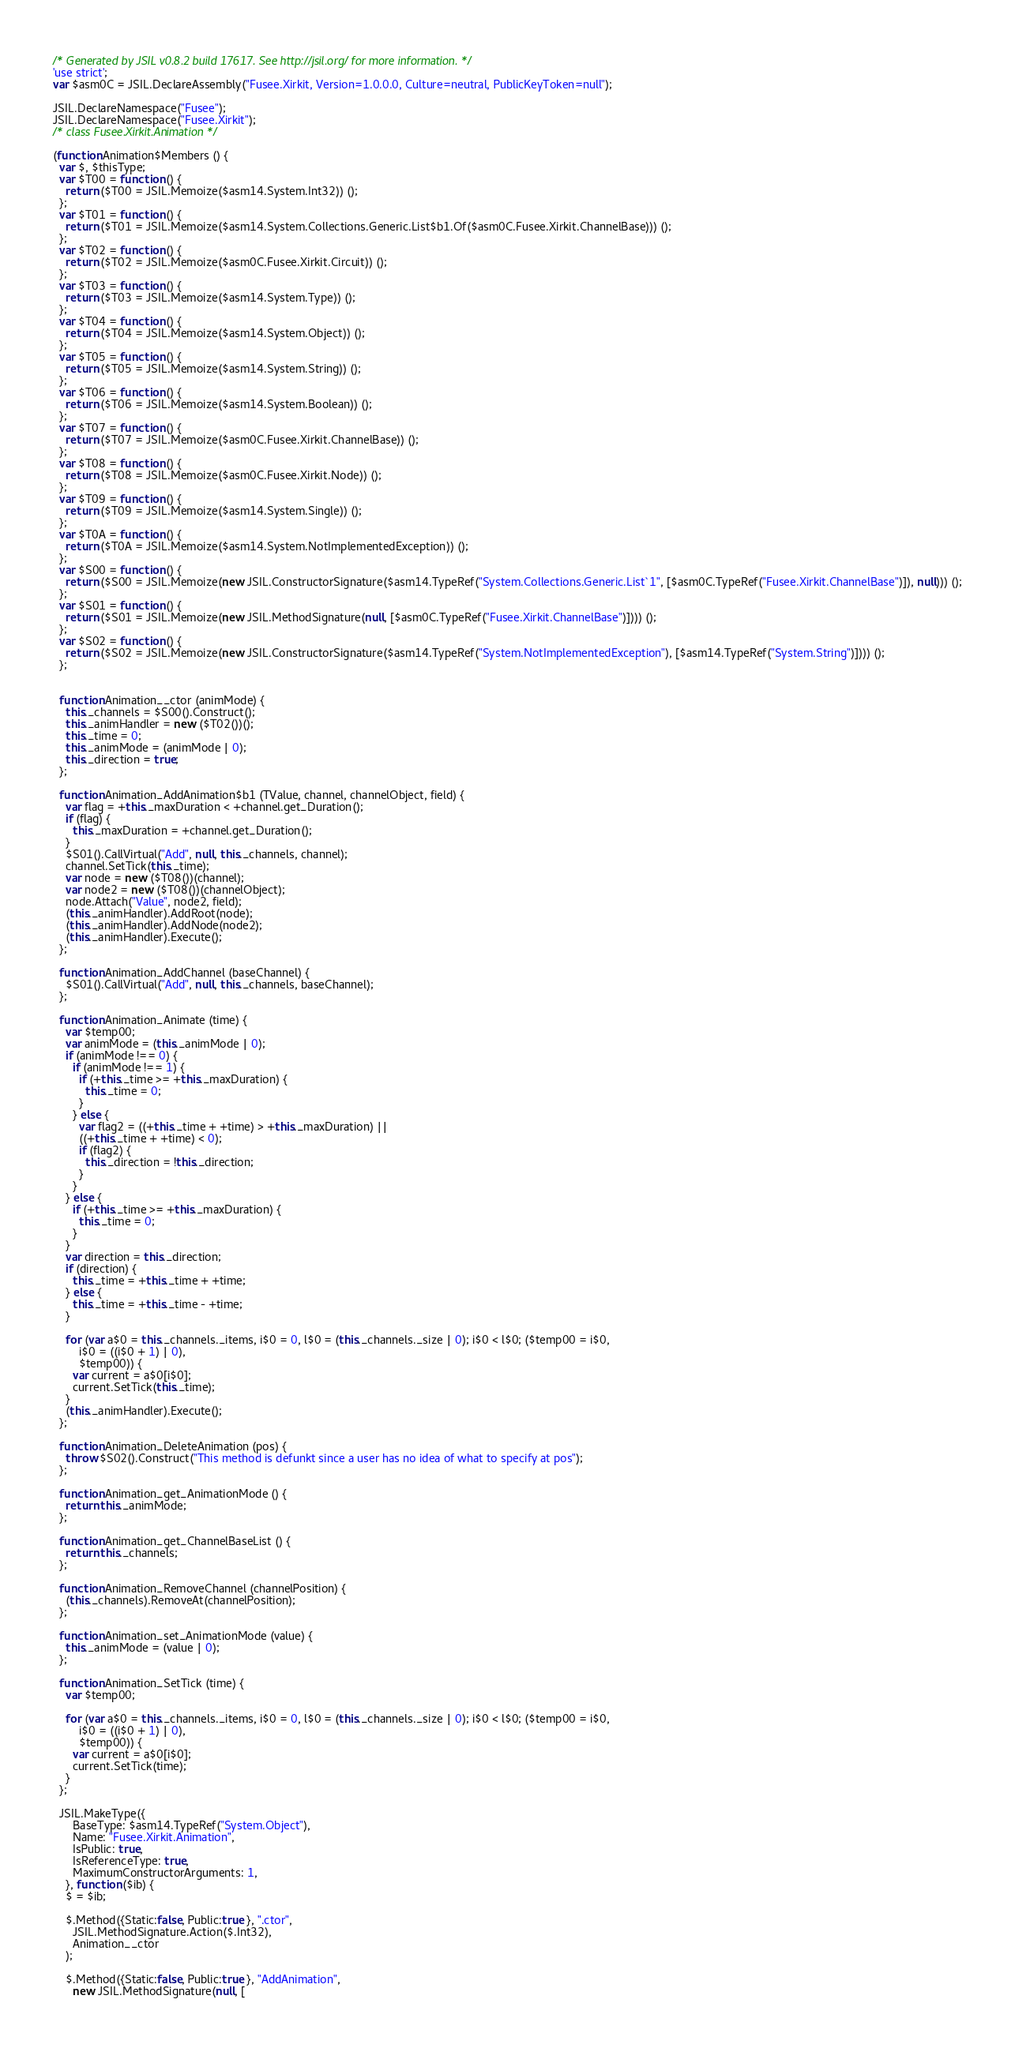Convert code to text. <code><loc_0><loc_0><loc_500><loc_500><_JavaScript_>/* Generated by JSIL v0.8.2 build 17617. See http://jsil.org/ for more information. */ 
'use strict';
var $asm0C = JSIL.DeclareAssembly("Fusee.Xirkit, Version=1.0.0.0, Culture=neutral, PublicKeyToken=null");

JSIL.DeclareNamespace("Fusee");
JSIL.DeclareNamespace("Fusee.Xirkit");
/* class Fusee.Xirkit.Animation */ 

(function Animation$Members () {
  var $, $thisType;
  var $T00 = function () {
    return ($T00 = JSIL.Memoize($asm14.System.Int32)) ();
  };
  var $T01 = function () {
    return ($T01 = JSIL.Memoize($asm14.System.Collections.Generic.List$b1.Of($asm0C.Fusee.Xirkit.ChannelBase))) ();
  };
  var $T02 = function () {
    return ($T02 = JSIL.Memoize($asm0C.Fusee.Xirkit.Circuit)) ();
  };
  var $T03 = function () {
    return ($T03 = JSIL.Memoize($asm14.System.Type)) ();
  };
  var $T04 = function () {
    return ($T04 = JSIL.Memoize($asm14.System.Object)) ();
  };
  var $T05 = function () {
    return ($T05 = JSIL.Memoize($asm14.System.String)) ();
  };
  var $T06 = function () {
    return ($T06 = JSIL.Memoize($asm14.System.Boolean)) ();
  };
  var $T07 = function () {
    return ($T07 = JSIL.Memoize($asm0C.Fusee.Xirkit.ChannelBase)) ();
  };
  var $T08 = function () {
    return ($T08 = JSIL.Memoize($asm0C.Fusee.Xirkit.Node)) ();
  };
  var $T09 = function () {
    return ($T09 = JSIL.Memoize($asm14.System.Single)) ();
  };
  var $T0A = function () {
    return ($T0A = JSIL.Memoize($asm14.System.NotImplementedException)) ();
  };
  var $S00 = function () {
    return ($S00 = JSIL.Memoize(new JSIL.ConstructorSignature($asm14.TypeRef("System.Collections.Generic.List`1", [$asm0C.TypeRef("Fusee.Xirkit.ChannelBase")]), null))) ();
  };
  var $S01 = function () {
    return ($S01 = JSIL.Memoize(new JSIL.MethodSignature(null, [$asm0C.TypeRef("Fusee.Xirkit.ChannelBase")]))) ();
  };
  var $S02 = function () {
    return ($S02 = JSIL.Memoize(new JSIL.ConstructorSignature($asm14.TypeRef("System.NotImplementedException"), [$asm14.TypeRef("System.String")]))) ();
  };


  function Animation__ctor (animMode) {
    this._channels = $S00().Construct();
    this._animHandler = new ($T02())();
    this._time = 0;
    this._animMode = (animMode | 0);
    this._direction = true;
  }; 

  function Animation_AddAnimation$b1 (TValue, channel, channelObject, field) {
    var flag = +this._maxDuration < +channel.get_Duration();
    if (flag) {
      this._maxDuration = +channel.get_Duration();
    }
    $S01().CallVirtual("Add", null, this._channels, channel);
    channel.SetTick(this._time);
    var node = new ($T08())(channel);
    var node2 = new ($T08())(channelObject);
    node.Attach("Value", node2, field);
    (this._animHandler).AddRoot(node);
    (this._animHandler).AddNode(node2);
    (this._animHandler).Execute();
  }; 

  function Animation_AddChannel (baseChannel) {
    $S01().CallVirtual("Add", null, this._channels, baseChannel);
  }; 

  function Animation_Animate (time) {
    var $temp00;
    var animMode = (this._animMode | 0);
    if (animMode !== 0) {
      if (animMode !== 1) {
        if (+this._time >= +this._maxDuration) {
          this._time = 0;
        }
      } else {
        var flag2 = ((+this._time + +time) > +this._maxDuration) || 
        ((+this._time + +time) < 0);
        if (flag2) {
          this._direction = !this._direction;
        }
      }
    } else {
      if (+this._time >= +this._maxDuration) {
        this._time = 0;
      }
    }
    var direction = this._direction;
    if (direction) {
      this._time = +this._time + +time;
    } else {
      this._time = +this._time - +time;
    }

    for (var a$0 = this._channels._items, i$0 = 0, l$0 = (this._channels._size | 0); i$0 < l$0; ($temp00 = i$0, 
        i$0 = ((i$0 + 1) | 0), 
        $temp00)) {
      var current = a$0[i$0];
      current.SetTick(this._time);
    }
    (this._animHandler).Execute();
  }; 

  function Animation_DeleteAnimation (pos) {
    throw $S02().Construct("This method is defunkt since a user has no idea of what to specify at pos");
  }; 

  function Animation_get_AnimationMode () {
    return this._animMode;
  }; 

  function Animation_get_ChannelBaseList () {
    return this._channels;
  }; 

  function Animation_RemoveChannel (channelPosition) {
    (this._channels).RemoveAt(channelPosition);
  }; 

  function Animation_set_AnimationMode (value) {
    this._animMode = (value | 0);
  }; 

  function Animation_SetTick (time) {
    var $temp00;

    for (var a$0 = this._channels._items, i$0 = 0, l$0 = (this._channels._size | 0); i$0 < l$0; ($temp00 = i$0, 
        i$0 = ((i$0 + 1) | 0), 
        $temp00)) {
      var current = a$0[i$0];
      current.SetTick(time);
    }
  }; 

  JSIL.MakeType({
      BaseType: $asm14.TypeRef("System.Object"), 
      Name: "Fusee.Xirkit.Animation", 
      IsPublic: true, 
      IsReferenceType: true, 
      MaximumConstructorArguments: 1, 
    }, function ($ib) {
    $ = $ib;

    $.Method({Static:false, Public:true }, ".ctor", 
      JSIL.MethodSignature.Action($.Int32), 
      Animation__ctor
    );

    $.Method({Static:false, Public:true }, "AddAnimation", 
      new JSIL.MethodSignature(null, [</code> 